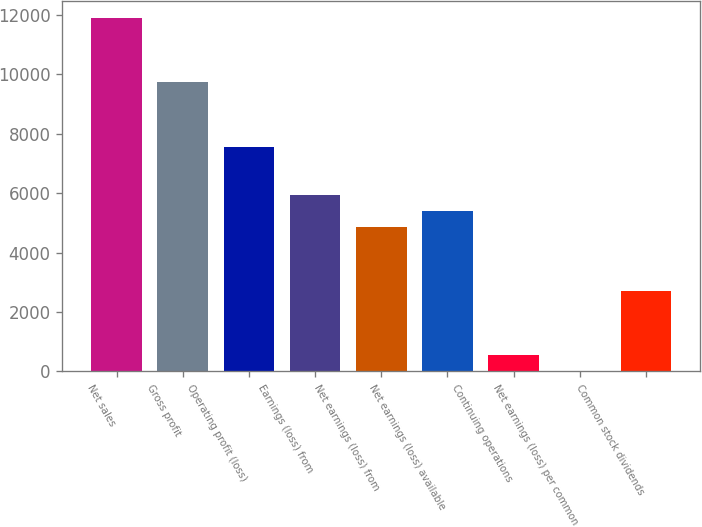<chart> <loc_0><loc_0><loc_500><loc_500><bar_chart><fcel>Net sales<fcel>Gross profit<fcel>Operating profit (loss)<fcel>Earnings (loss) from<fcel>Net earnings (loss) from<fcel>Net earnings (loss) available<fcel>Continuing operations<fcel>Net earnings (loss) per common<fcel>Common stock dividends<nl><fcel>11877<fcel>9717.84<fcel>7558.64<fcel>5939.24<fcel>4859.64<fcel>5399.44<fcel>541.24<fcel>1.44<fcel>2700.44<nl></chart> 